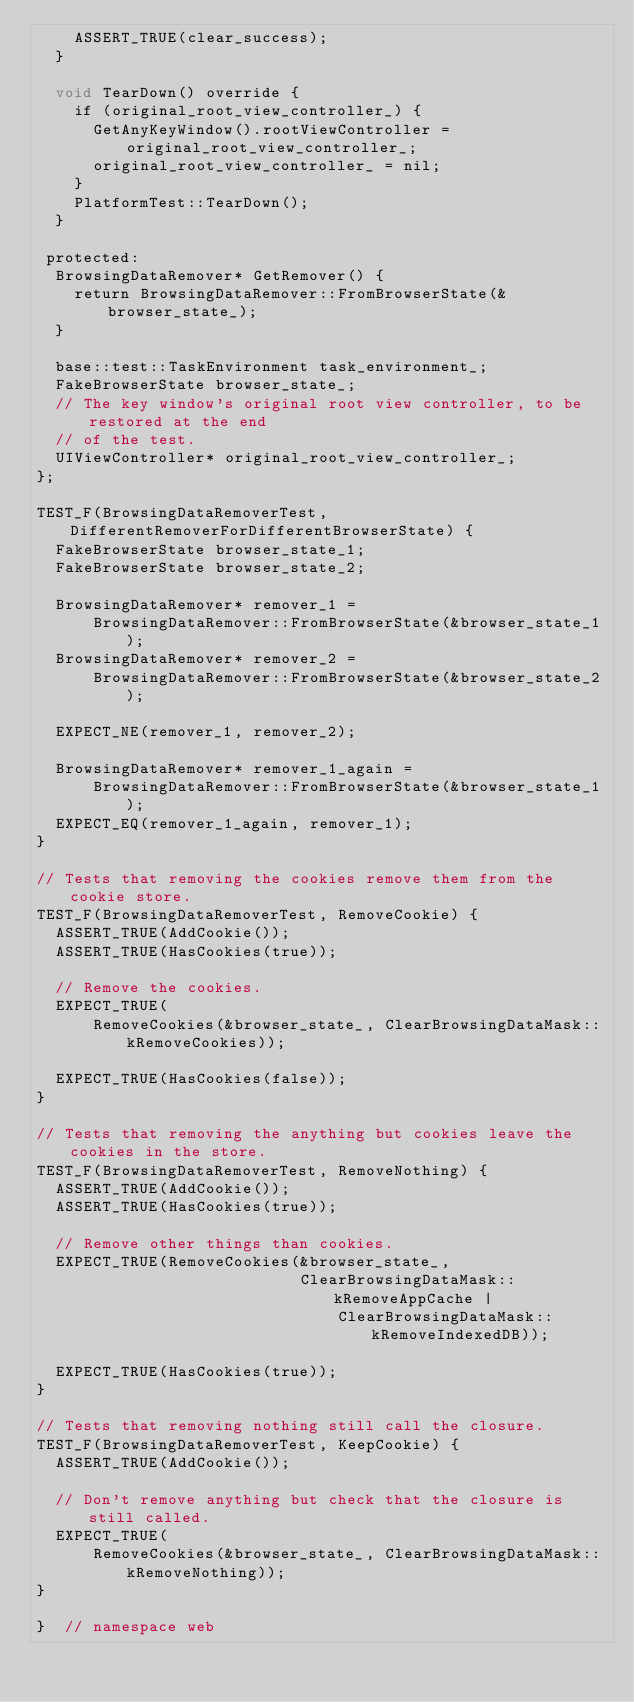Convert code to text. <code><loc_0><loc_0><loc_500><loc_500><_ObjectiveC_>    ASSERT_TRUE(clear_success);
  }

  void TearDown() override {
    if (original_root_view_controller_) {
      GetAnyKeyWindow().rootViewController = original_root_view_controller_;
      original_root_view_controller_ = nil;
    }
    PlatformTest::TearDown();
  }

 protected:
  BrowsingDataRemover* GetRemover() {
    return BrowsingDataRemover::FromBrowserState(&browser_state_);
  }

  base::test::TaskEnvironment task_environment_;
  FakeBrowserState browser_state_;
  // The key window's original root view controller, to be  restored at the end
  // of the test.
  UIViewController* original_root_view_controller_;
};

TEST_F(BrowsingDataRemoverTest, DifferentRemoverForDifferentBrowserState) {
  FakeBrowserState browser_state_1;
  FakeBrowserState browser_state_2;

  BrowsingDataRemover* remover_1 =
      BrowsingDataRemover::FromBrowserState(&browser_state_1);
  BrowsingDataRemover* remover_2 =
      BrowsingDataRemover::FromBrowserState(&browser_state_2);

  EXPECT_NE(remover_1, remover_2);

  BrowsingDataRemover* remover_1_again =
      BrowsingDataRemover::FromBrowserState(&browser_state_1);
  EXPECT_EQ(remover_1_again, remover_1);
}

// Tests that removing the cookies remove them from the cookie store.
TEST_F(BrowsingDataRemoverTest, RemoveCookie) {
  ASSERT_TRUE(AddCookie());
  ASSERT_TRUE(HasCookies(true));

  // Remove the cookies.
  EXPECT_TRUE(
      RemoveCookies(&browser_state_, ClearBrowsingDataMask::kRemoveCookies));

  EXPECT_TRUE(HasCookies(false));
}

// Tests that removing the anything but cookies leave the cookies in the store.
TEST_F(BrowsingDataRemoverTest, RemoveNothing) {
  ASSERT_TRUE(AddCookie());
  ASSERT_TRUE(HasCookies(true));

  // Remove other things than cookies.
  EXPECT_TRUE(RemoveCookies(&browser_state_,
                            ClearBrowsingDataMask::kRemoveAppCache |
                                ClearBrowsingDataMask::kRemoveIndexedDB));

  EXPECT_TRUE(HasCookies(true));
}

// Tests that removing nothing still call the closure.
TEST_F(BrowsingDataRemoverTest, KeepCookie) {
  ASSERT_TRUE(AddCookie());

  // Don't remove anything but check that the closure is still called.
  EXPECT_TRUE(
      RemoveCookies(&browser_state_, ClearBrowsingDataMask::kRemoveNothing));
}

}  // namespace web
</code> 